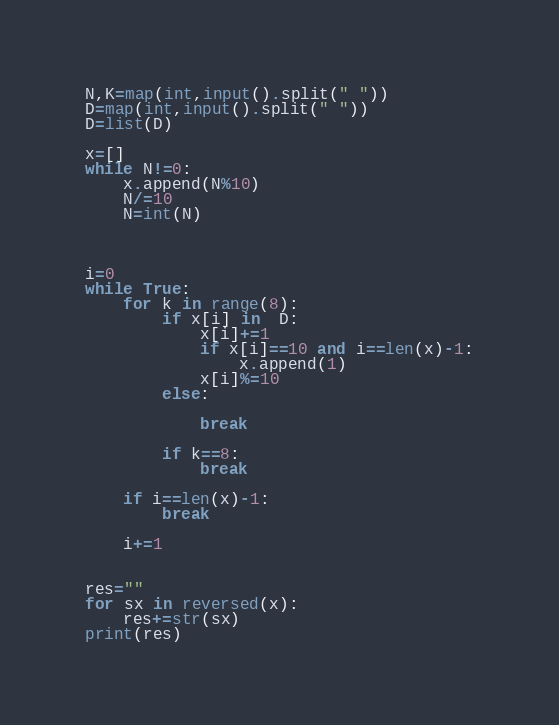Convert code to text. <code><loc_0><loc_0><loc_500><loc_500><_Python_>N,K=map(int,input().split(" "))
D=map(int,input().split(" "))
D=list(D)

x=[]
while N!=0:
    x.append(N%10)
    N/=10
    N=int(N)



i=0
while True:    
    for k in range(8):
        if x[i] in  D:
            x[i]+=1
            if x[i]==10 and i==len(x)-1:
                x.append(1)
            x[i]%=10
        else:

            break

        if k==8:
            break

    if i==len(x)-1:
        break

    i+=1


res=""
for sx in reversed(x):
    res+=str(sx)
print(res)
</code> 